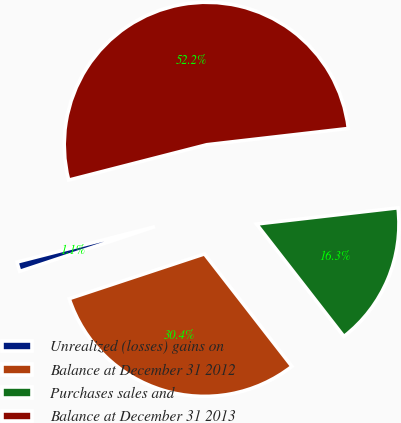Convert chart to OTSL. <chart><loc_0><loc_0><loc_500><loc_500><pie_chart><fcel>Unrealized (losses) gains on<fcel>Balance at December 31 2012<fcel>Purchases sales and<fcel>Balance at December 31 2013<nl><fcel>1.09%<fcel>30.43%<fcel>16.3%<fcel>52.17%<nl></chart> 